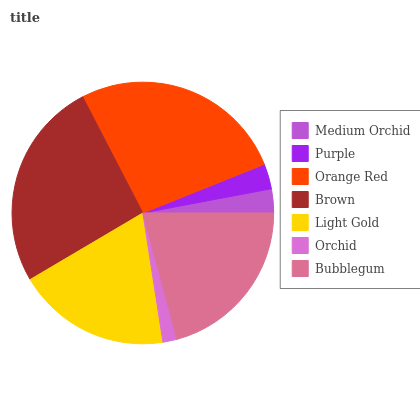Is Orchid the minimum?
Answer yes or no. Yes. Is Orange Red the maximum?
Answer yes or no. Yes. Is Purple the minimum?
Answer yes or no. No. Is Purple the maximum?
Answer yes or no. No. Is Purple greater than Medium Orchid?
Answer yes or no. Yes. Is Medium Orchid less than Purple?
Answer yes or no. Yes. Is Medium Orchid greater than Purple?
Answer yes or no. No. Is Purple less than Medium Orchid?
Answer yes or no. No. Is Light Gold the high median?
Answer yes or no. Yes. Is Light Gold the low median?
Answer yes or no. Yes. Is Purple the high median?
Answer yes or no. No. Is Orchid the low median?
Answer yes or no. No. 